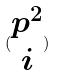<formula> <loc_0><loc_0><loc_500><loc_500>( \begin{matrix} p ^ { 2 } \\ i \end{matrix} )</formula> 